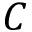<formula> <loc_0><loc_0><loc_500><loc_500>C</formula> 